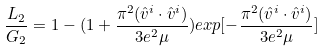Convert formula to latex. <formula><loc_0><loc_0><loc_500><loc_500>\frac { L _ { 2 } } { G _ { 2 } } = 1 - ( 1 + \frac { \pi ^ { 2 } ( \hat { v } ^ { i } \cdot \hat { v } ^ { i } ) } { 3 e ^ { 2 } \mu } ) e x p [ - \frac { \pi ^ { 2 } ( \hat { v } ^ { i } \cdot \hat { v } ^ { i } ) } { 3 e ^ { 2 } \mu } ]</formula> 